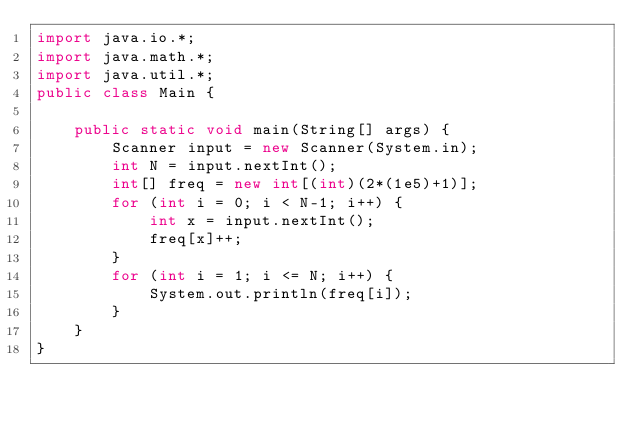Convert code to text. <code><loc_0><loc_0><loc_500><loc_500><_Java_>import java.io.*;
import java.math.*;
import java.util.*;
public class Main {

	public static void main(String[] args) {
		Scanner input = new Scanner(System.in);
		int N = input.nextInt();
		int[] freq = new int[(int)(2*(1e5)+1)];
		for (int i = 0; i < N-1; i++) {
			int x = input.nextInt();
			freq[x]++;
		}
		for (int i = 1; i <= N; i++) {
			System.out.println(freq[i]);
		}
	}
}</code> 